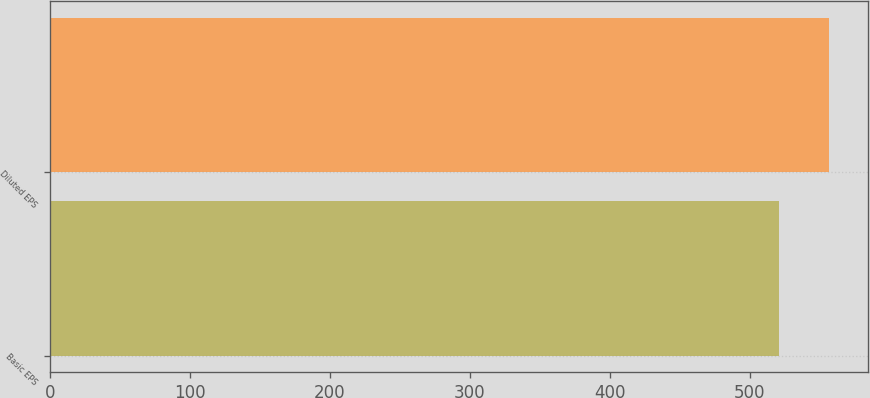Convert chart to OTSL. <chart><loc_0><loc_0><loc_500><loc_500><bar_chart><fcel>Basic EPS<fcel>Diluted EPS<nl><fcel>520.5<fcel>556.5<nl></chart> 